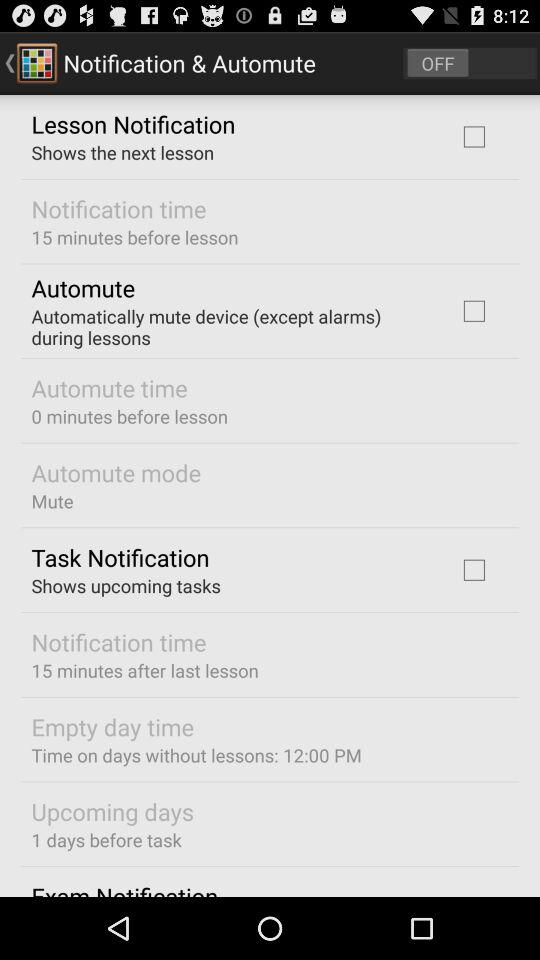What is the "Notification time" after last lesson? The "Notification time" is 15 minutes. 